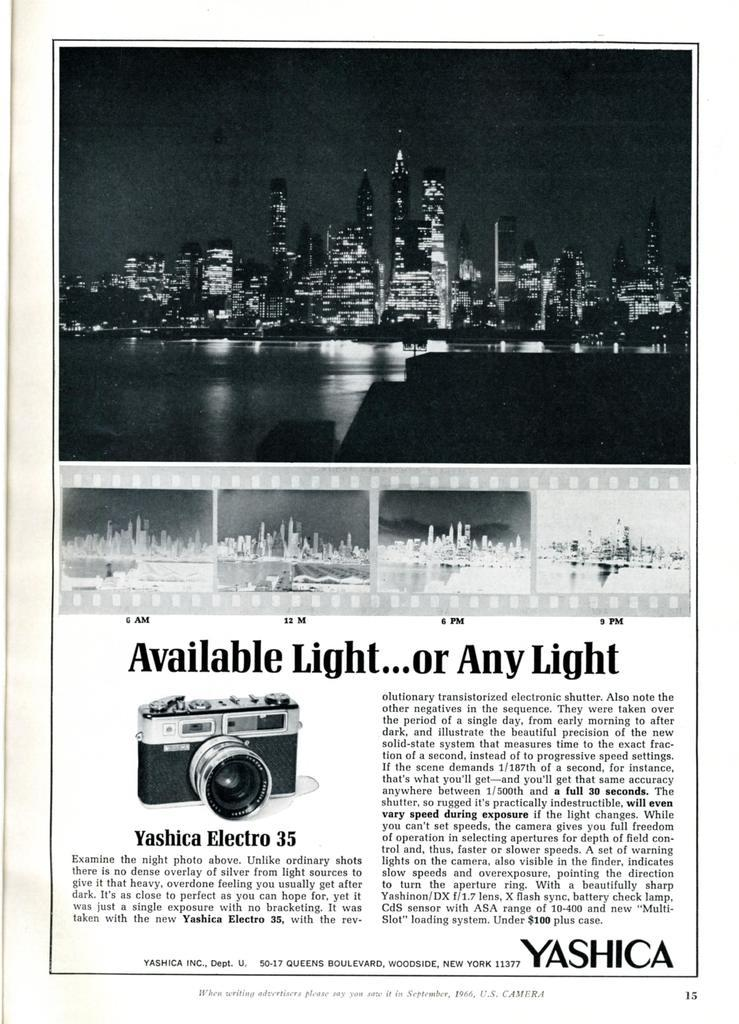Provide a one-sentence caption for the provided image. A black and white advertisement for a Yashica Electro 35 camera. 